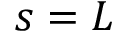<formula> <loc_0><loc_0><loc_500><loc_500>s = L</formula> 